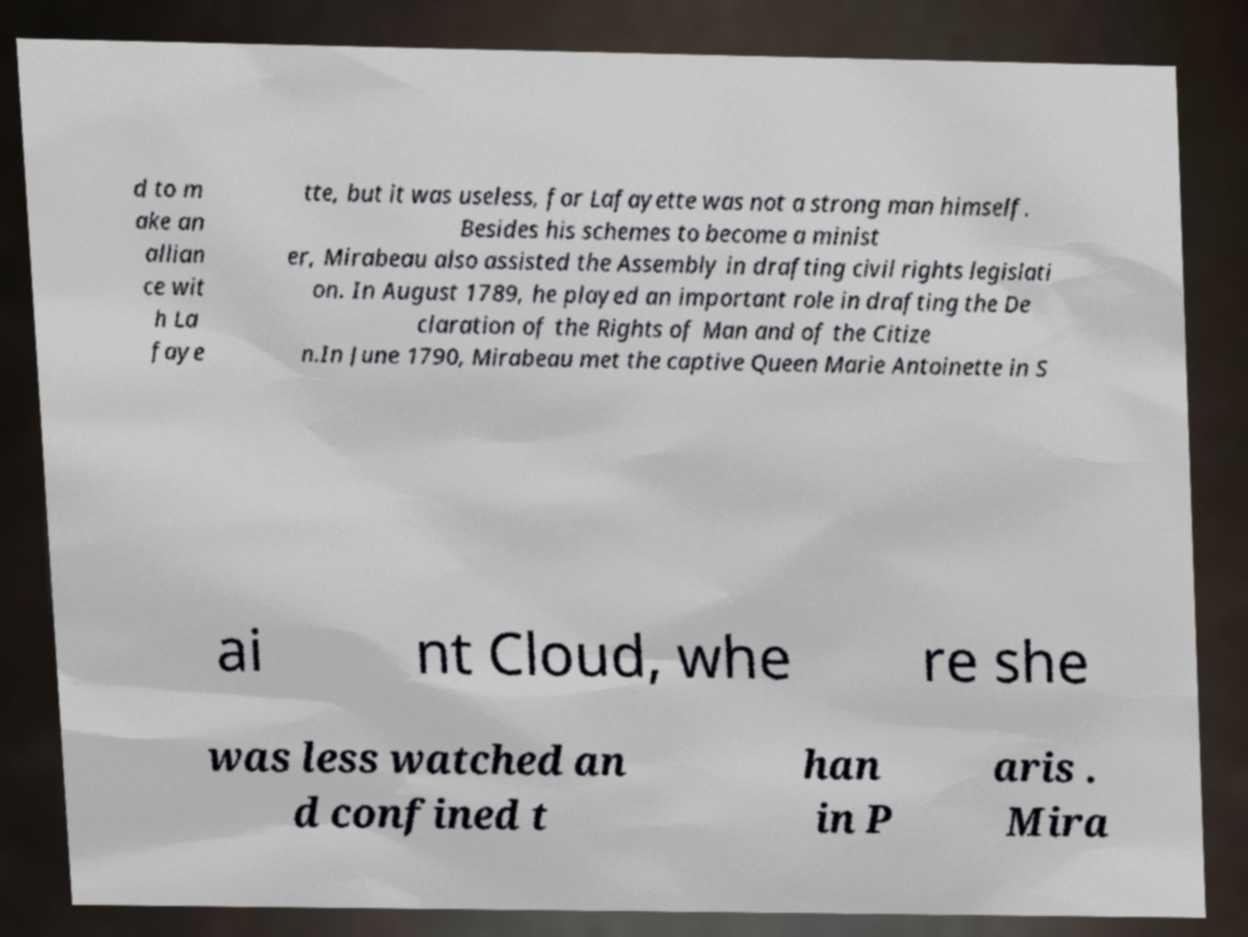What messages or text are displayed in this image? I need them in a readable, typed format. d to m ake an allian ce wit h La faye tte, but it was useless, for Lafayette was not a strong man himself. Besides his schemes to become a minist er, Mirabeau also assisted the Assembly in drafting civil rights legislati on. In August 1789, he played an important role in drafting the De claration of the Rights of Man and of the Citize n.In June 1790, Mirabeau met the captive Queen Marie Antoinette in S ai nt Cloud, whe re she was less watched an d confined t han in P aris . Mira 